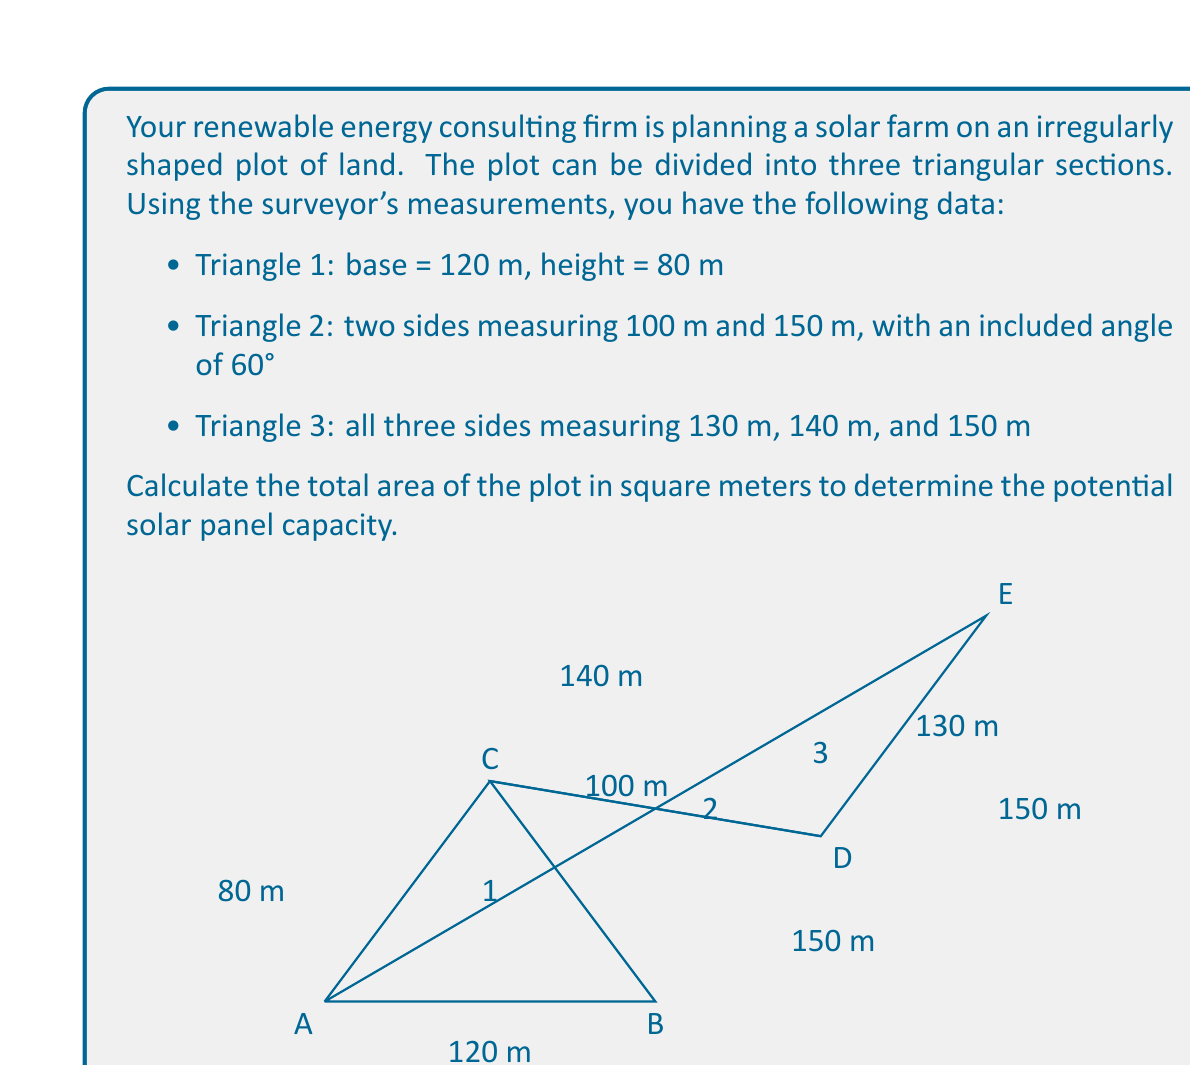Solve this math problem. To find the total area of the irregularly shaped plot, we need to calculate the areas of the three triangular sections and sum them up.

1. Area of Triangle 1:
   We can use the formula $A = \frac{1}{2} \times base \times height$
   $$A_1 = \frac{1}{2} \times 120 \times 80 = 4800 \text{ m}^2$$

2. Area of Triangle 2:
   We can use the formula $A = \frac{1}{2} \times a \times b \times \sin(C)$, where $a$ and $b$ are the two known sides and $C$ is the included angle.
   $$A_2 = \frac{1}{2} \times 100 \times 150 \times \sin(60°) = 6495.19 \text{ m}^2$$

3. Area of Triangle 3:
   We can use Heron's formula: $A = \sqrt{s(s-a)(s-b)(s-c)}$, where $s$ is the semi-perimeter.
   
   First, calculate the semi-perimeter:
   $$s = \frac{130 + 140 + 150}{2} = 210 \text{ m}$$
   
   Then apply Heron's formula:
   $$A_3 = \sqrt{210(210-130)(210-140)(210-150)}$$
   $$A_3 = \sqrt{210 \times 80 \times 70 \times 60} = 8132.69 \text{ m}^2$$

4. Total Area:
   Sum up the areas of all three triangles:
   $$A_{total} = A_1 + A_2 + A_3 = 4800 + 6495.19 + 8132.69 = 19427.88 \text{ m}^2$$
Answer: The total area of the irregularly shaped plot for the solar farm is approximately 19,427.88 square meters. 